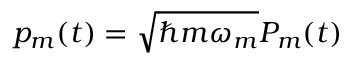Convert formula to latex. <formula><loc_0><loc_0><loc_500><loc_500>p _ { m } ( t ) = \sqrt { \hbar { m } \omega _ { m } } P _ { m } ( t )</formula> 